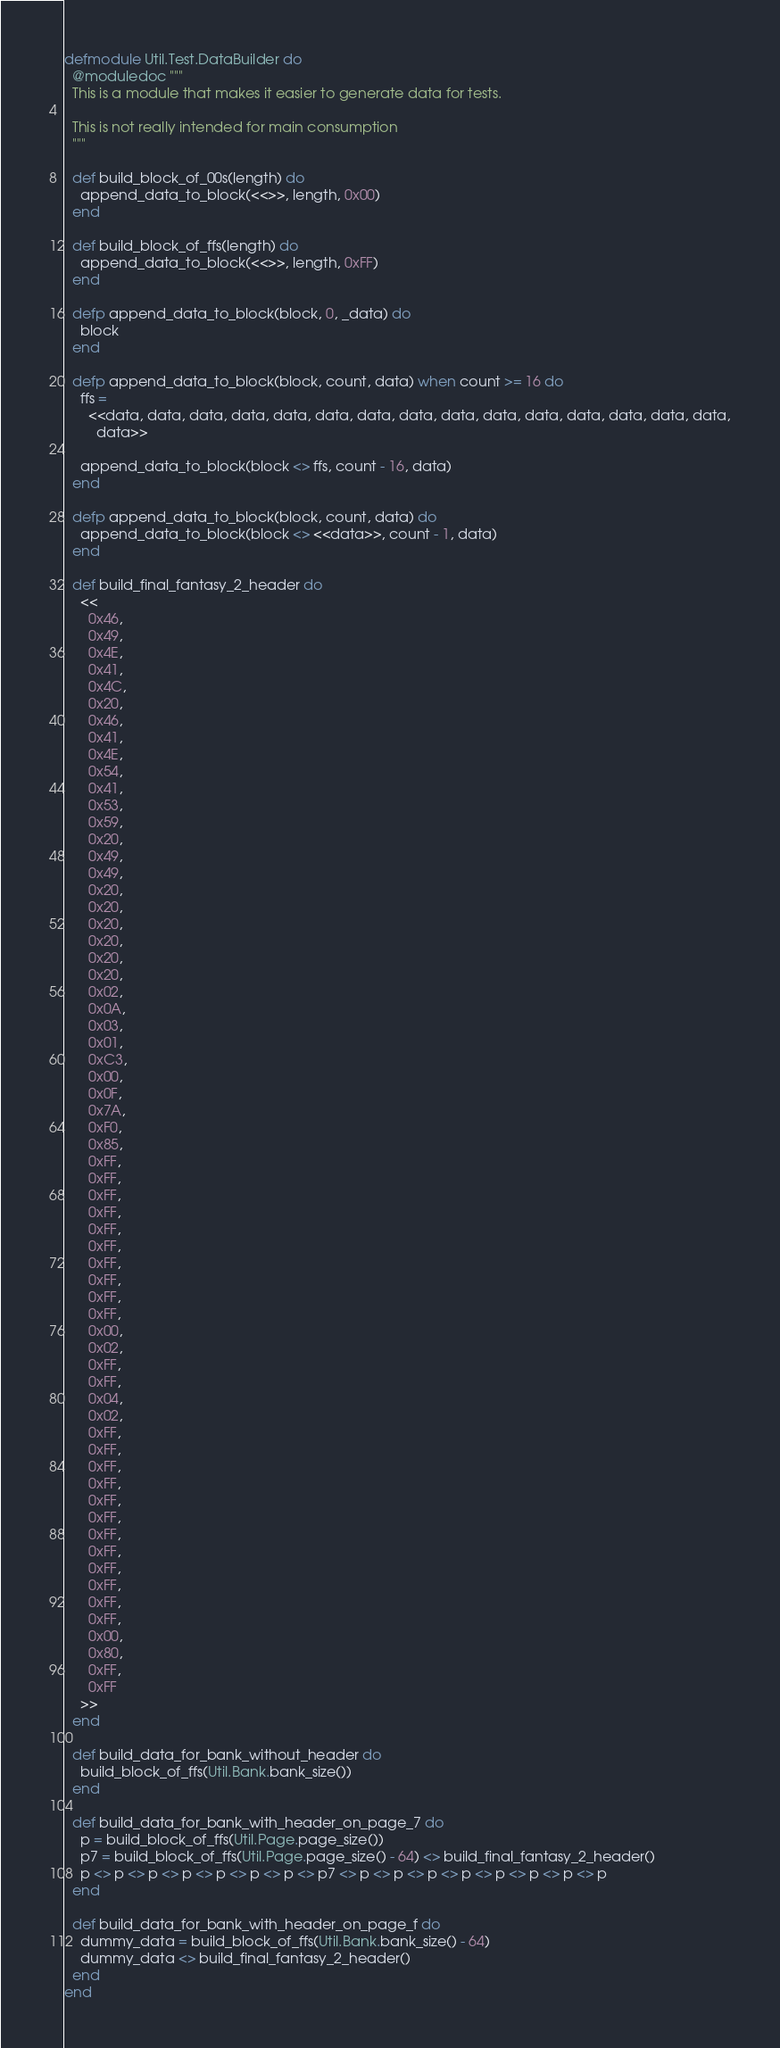Convert code to text. <code><loc_0><loc_0><loc_500><loc_500><_Elixir_>defmodule Util.Test.DataBuilder do
  @moduledoc """
  This is a module that makes it easier to generate data for tests.

  This is not really intended for main consumption
  """

  def build_block_of_00s(length) do
    append_data_to_block(<<>>, length, 0x00)
  end

  def build_block_of_ffs(length) do
    append_data_to_block(<<>>, length, 0xFF)
  end

  defp append_data_to_block(block, 0, _data) do
    block
  end

  defp append_data_to_block(block, count, data) when count >= 16 do
    ffs =
      <<data, data, data, data, data, data, data, data, data, data, data, data, data, data, data,
        data>>

    append_data_to_block(block <> ffs, count - 16, data)
  end

  defp append_data_to_block(block, count, data) do
    append_data_to_block(block <> <<data>>, count - 1, data)
  end

  def build_final_fantasy_2_header do
    <<
      0x46,
      0x49,
      0x4E,
      0x41,
      0x4C,
      0x20,
      0x46,
      0x41,
      0x4E,
      0x54,
      0x41,
      0x53,
      0x59,
      0x20,
      0x49,
      0x49,
      0x20,
      0x20,
      0x20,
      0x20,
      0x20,
      0x20,
      0x02,
      0x0A,
      0x03,
      0x01,
      0xC3,
      0x00,
      0x0F,
      0x7A,
      0xF0,
      0x85,
      0xFF,
      0xFF,
      0xFF,
      0xFF,
      0xFF,
      0xFF,
      0xFF,
      0xFF,
      0xFF,
      0xFF,
      0x00,
      0x02,
      0xFF,
      0xFF,
      0x04,
      0x02,
      0xFF,
      0xFF,
      0xFF,
      0xFF,
      0xFF,
      0xFF,
      0xFF,
      0xFF,
      0xFF,
      0xFF,
      0xFF,
      0xFF,
      0x00,
      0x80,
      0xFF,
      0xFF
    >>
  end

  def build_data_for_bank_without_header do
    build_block_of_ffs(Util.Bank.bank_size())
  end

  def build_data_for_bank_with_header_on_page_7 do
    p = build_block_of_ffs(Util.Page.page_size())
    p7 = build_block_of_ffs(Util.Page.page_size() - 64) <> build_final_fantasy_2_header()
    p <> p <> p <> p <> p <> p <> p <> p7 <> p <> p <> p <> p <> p <> p <> p <> p
  end

  def build_data_for_bank_with_header_on_page_f do
    dummy_data = build_block_of_ffs(Util.Bank.bank_size() - 64)
    dummy_data <> build_final_fantasy_2_header()
  end
end
</code> 